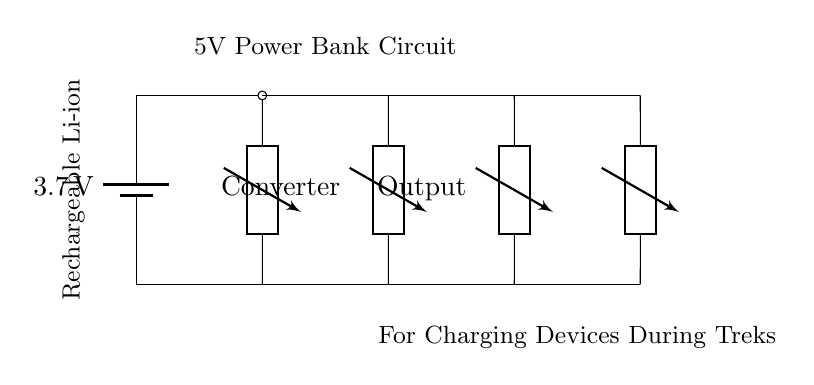What is the type of battery used in this circuit? The circuit diagram indicates a rechargeable Li-ion battery, as it is labeled directly next to the battery symbol.
Answer: Rechargeable Li-ion What is the output voltage of the boost converter? The output voltage of the boost converter is typically specified at 5V for USB charging, which can be inferred as it connects to the USB output labeled in the circuit.
Answer: 5V What is the purpose of the charging circuit? The charging circuit is designed to manage the charging process of the battery and ensure proper power storage, which is indicated by its connection to the battery.
Answer: Charge the battery How many components are involved in the power bank circuit? The circuit contains four main components: the battery, charging circuit, boost converter, and USB output, all of which are explicitly shown in the diagram.
Answer: Four Is there a device connected to the USB output? The circuit clearly shows an output labeled "Device" connected to the USB output, indicating that it is meant to charge an external device.
Answer: Yes What is the main function of the boost converter? The boost converter's role is to step up the voltage from the battery to the required level for USB charging, which connects to both the battery and the USB output.
Answer: Step up voltage What does the circuit indicate about usage during treks? The label at the bottom emphasizes its functionality for charging devices during treks, suggesting practicality for outdoor activities where power might be scarce.
Answer: Charging devices during treks 